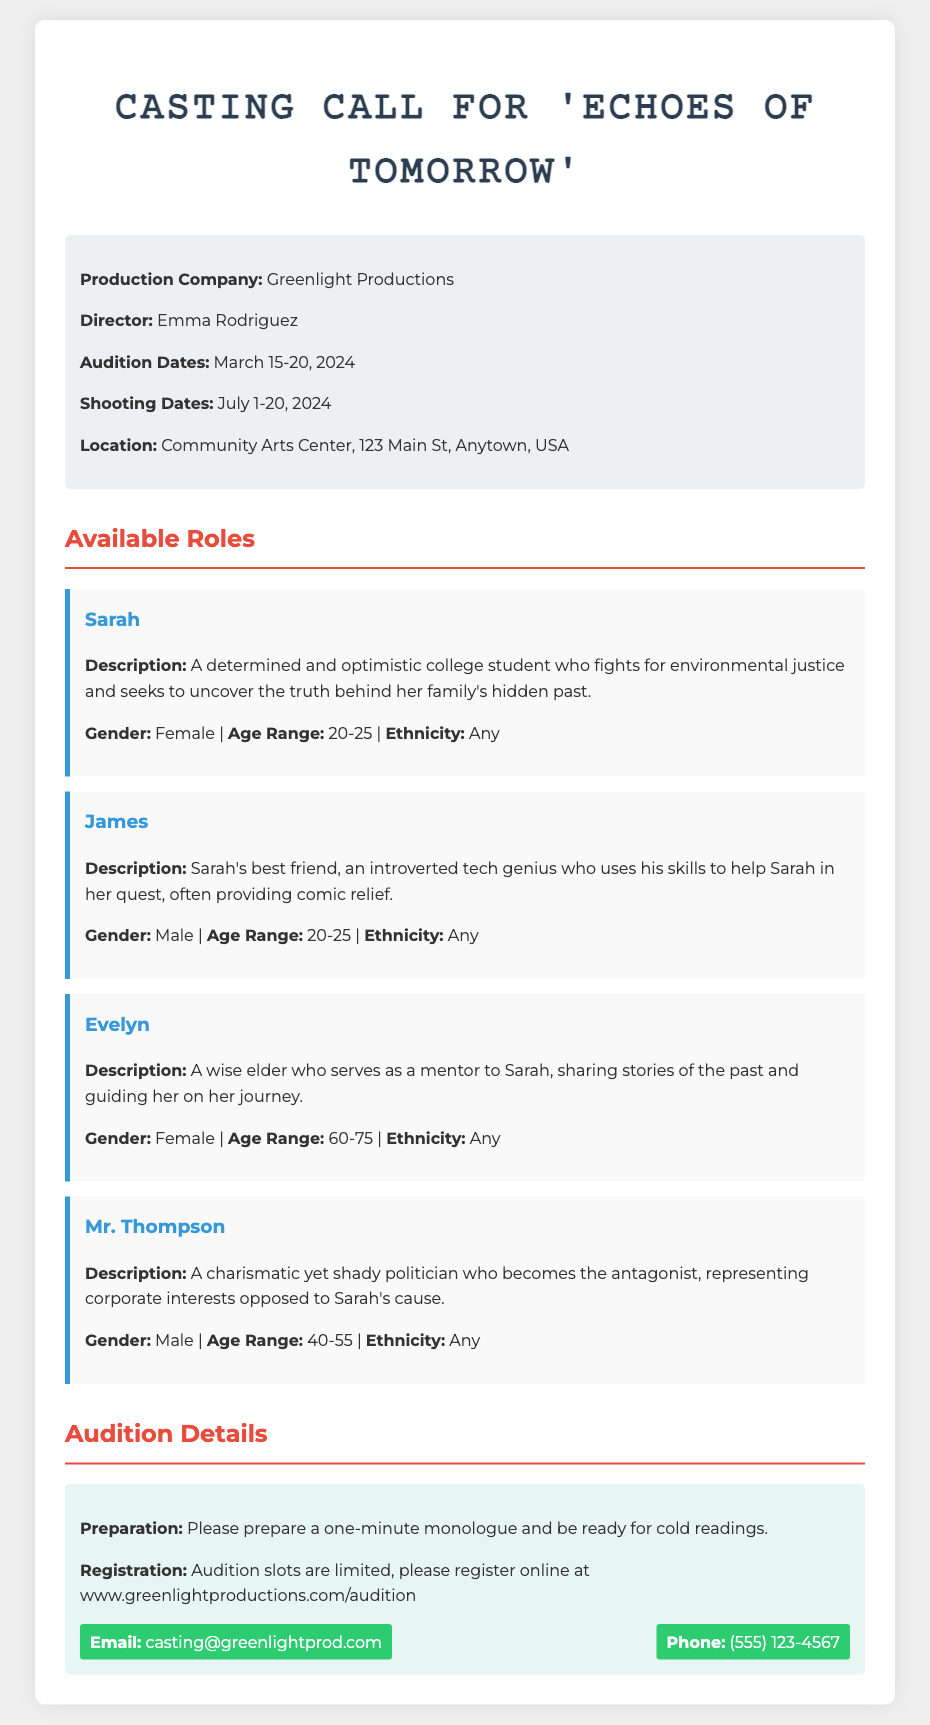what is the title of the film? The title of the film is stated prominently at the beginning of the document.
Answer: Echoes of Tomorrow who is the director of the film? The director is mentioned in the production information section of the document.
Answer: Emma Rodriguez what are the audition dates? The audition dates are clearly listed under the production information section.
Answer: March 15-20, 2024 how many roles are available in the casting call? The available roles are detailed in the section titled "Available Roles".
Answer: Four what is the age range for the character Sarah? The age range is specified in the character description for Sarah.
Answer: 20-25 what genre or theme does Sarah's character represent? Sarah's character description highlights her fight for a specific cause, which indicates the theme.
Answer: Environmental justice what preparation is required for auditions? The preparation requirements are stated in the audition details section of the document.
Answer: One-minute monologue where can applicants register for auditions? The registration information is provided in the audition details section.
Answer: www.greenlightproductions.com/audition what is the phone number provided for contact? The phone number is included in the contact information section.
Answer: (555) 123-4567 